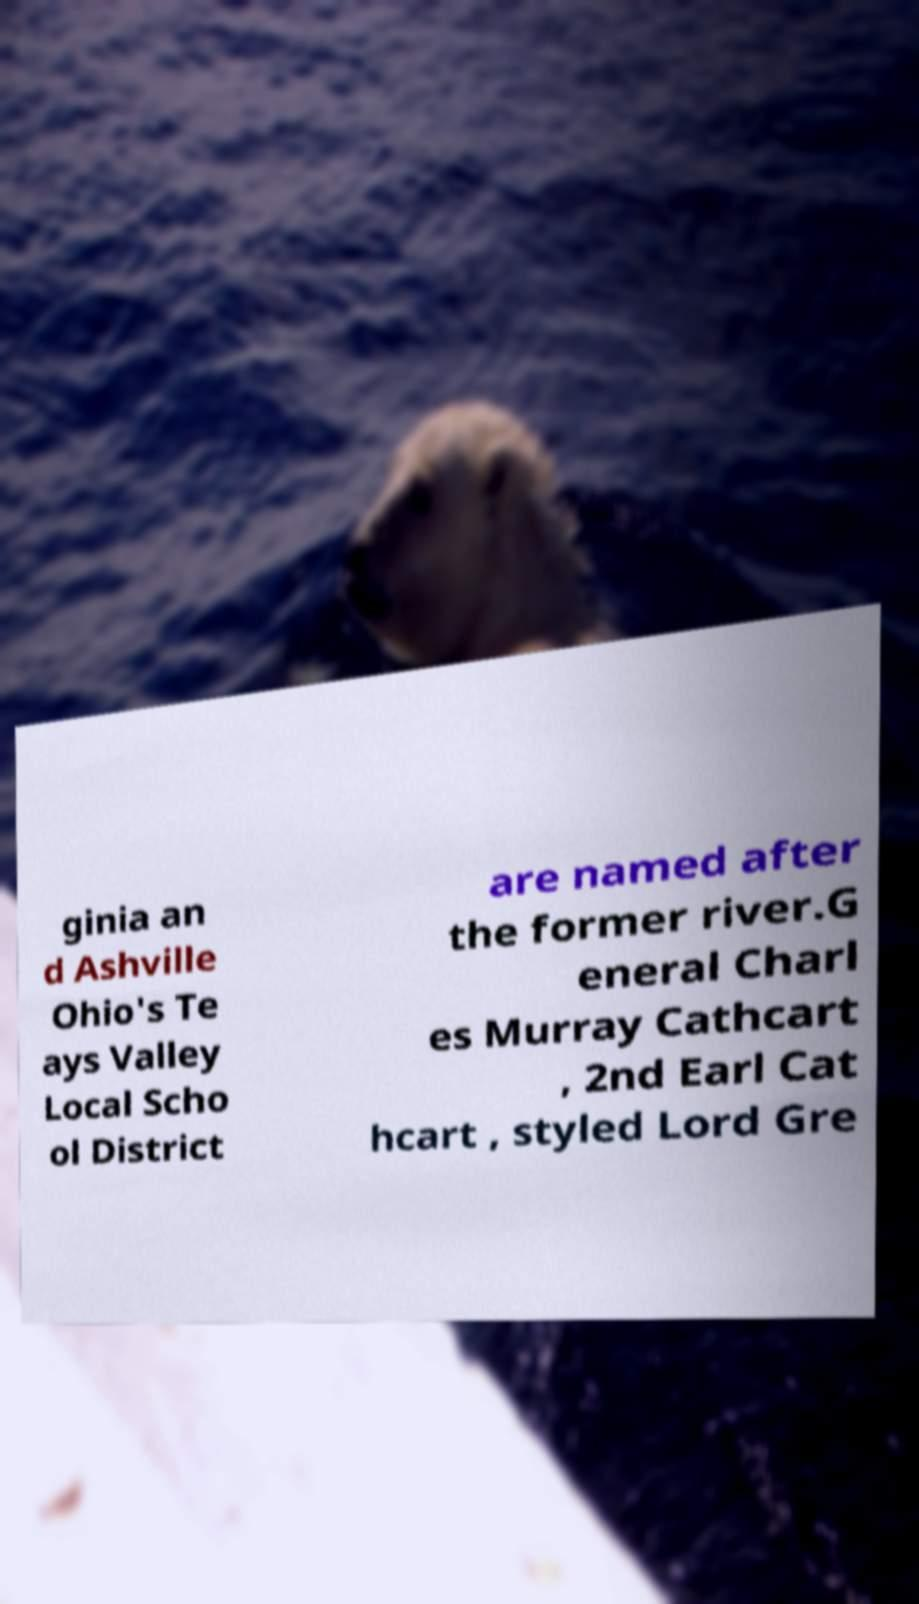I need the written content from this picture converted into text. Can you do that? ginia an d Ashville Ohio's Te ays Valley Local Scho ol District are named after the former river.G eneral Charl es Murray Cathcart , 2nd Earl Cat hcart , styled Lord Gre 